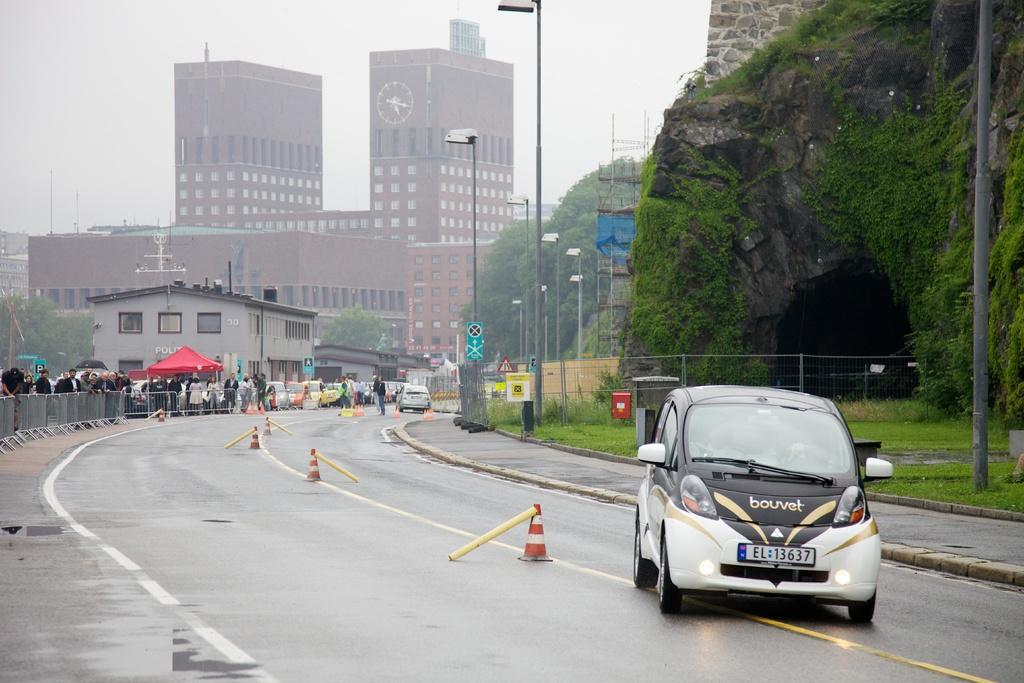Could you give a brief overview of what you see in this image? In the image in the center we can see few vehicles on the road. And we can see traffic poles,sign boards,poles,grass,plants,tent,hill,road and fence. In the background we can see the sky,clouds,trees,buildings,poles and group of people were standing. 